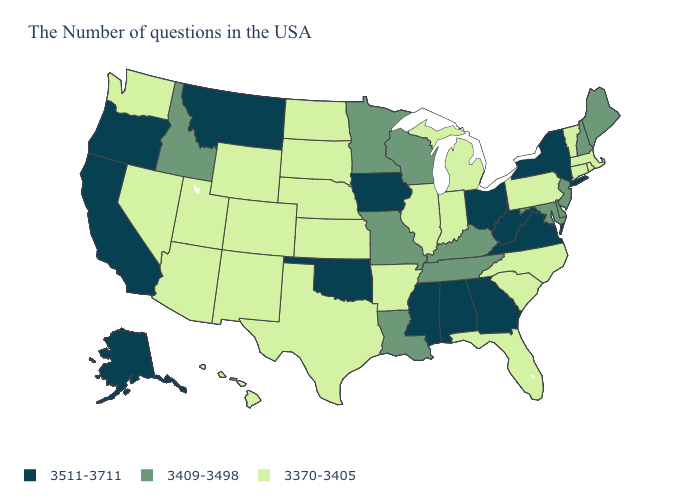Name the states that have a value in the range 3409-3498?
Answer briefly. Maine, New Hampshire, New Jersey, Delaware, Maryland, Kentucky, Tennessee, Wisconsin, Louisiana, Missouri, Minnesota, Idaho. Which states have the lowest value in the USA?
Write a very short answer. Massachusetts, Rhode Island, Vermont, Connecticut, Pennsylvania, North Carolina, South Carolina, Florida, Michigan, Indiana, Illinois, Arkansas, Kansas, Nebraska, Texas, South Dakota, North Dakota, Wyoming, Colorado, New Mexico, Utah, Arizona, Nevada, Washington, Hawaii. What is the highest value in the USA?
Be succinct. 3511-3711. What is the lowest value in the USA?
Concise answer only. 3370-3405. Which states have the lowest value in the South?
Concise answer only. North Carolina, South Carolina, Florida, Arkansas, Texas. What is the value of North Carolina?
Give a very brief answer. 3370-3405. Does Indiana have the same value as Delaware?
Write a very short answer. No. Does the map have missing data?
Quick response, please. No. Among the states that border Kentucky , which have the lowest value?
Be succinct. Indiana, Illinois. What is the highest value in states that border Virginia?
Give a very brief answer. 3511-3711. Name the states that have a value in the range 3409-3498?
Concise answer only. Maine, New Hampshire, New Jersey, Delaware, Maryland, Kentucky, Tennessee, Wisconsin, Louisiana, Missouri, Minnesota, Idaho. Name the states that have a value in the range 3409-3498?
Short answer required. Maine, New Hampshire, New Jersey, Delaware, Maryland, Kentucky, Tennessee, Wisconsin, Louisiana, Missouri, Minnesota, Idaho. Does the first symbol in the legend represent the smallest category?
Give a very brief answer. No. Name the states that have a value in the range 3370-3405?
Concise answer only. Massachusetts, Rhode Island, Vermont, Connecticut, Pennsylvania, North Carolina, South Carolina, Florida, Michigan, Indiana, Illinois, Arkansas, Kansas, Nebraska, Texas, South Dakota, North Dakota, Wyoming, Colorado, New Mexico, Utah, Arizona, Nevada, Washington, Hawaii. Which states have the highest value in the USA?
Give a very brief answer. New York, Virginia, West Virginia, Ohio, Georgia, Alabama, Mississippi, Iowa, Oklahoma, Montana, California, Oregon, Alaska. 